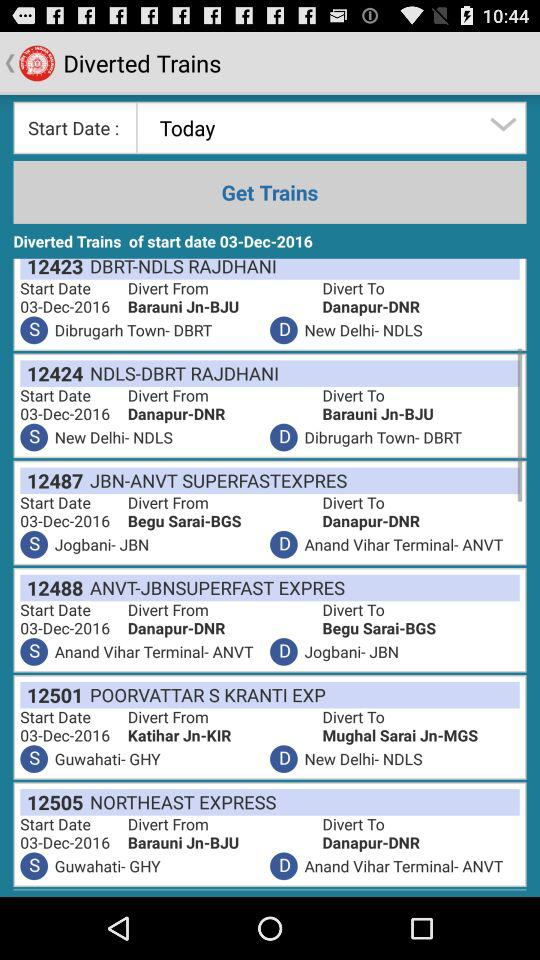What is the start date of train number 12423? The start date is December 3, 2016. 